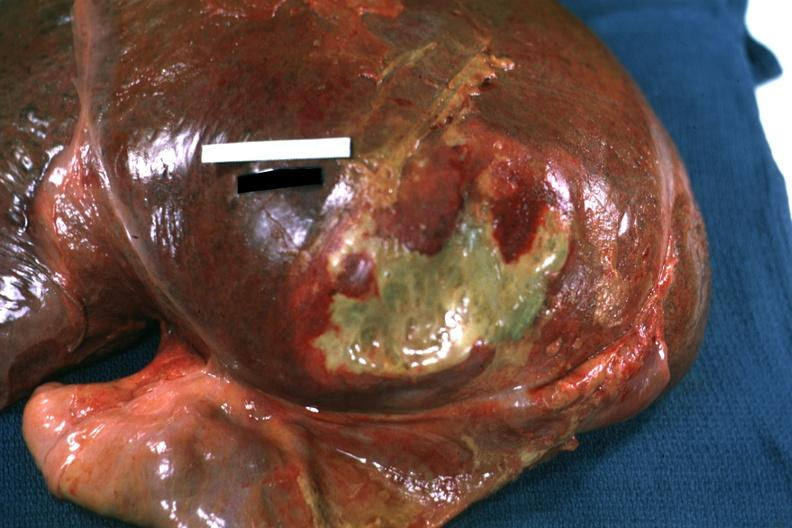s cortical nodule present?
Answer the question using a single word or phrase. No 